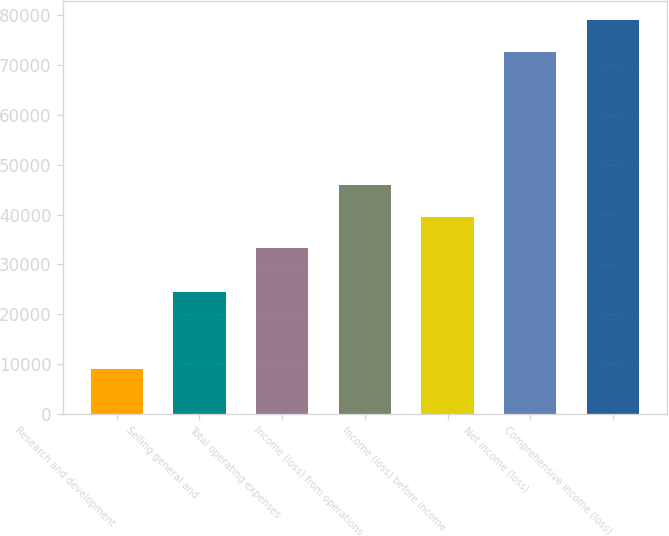<chart> <loc_0><loc_0><loc_500><loc_500><bar_chart><fcel>Research and development<fcel>Selling general and<fcel>Total operating expenses<fcel>Income (loss) from operations<fcel>Income (loss) before income<fcel>Net income (loss)<fcel>Comprehensive income (loss)<nl><fcel>8929<fcel>24483<fcel>33199<fcel>45940.6<fcel>39569.8<fcel>72634<fcel>79004.8<nl></chart> 